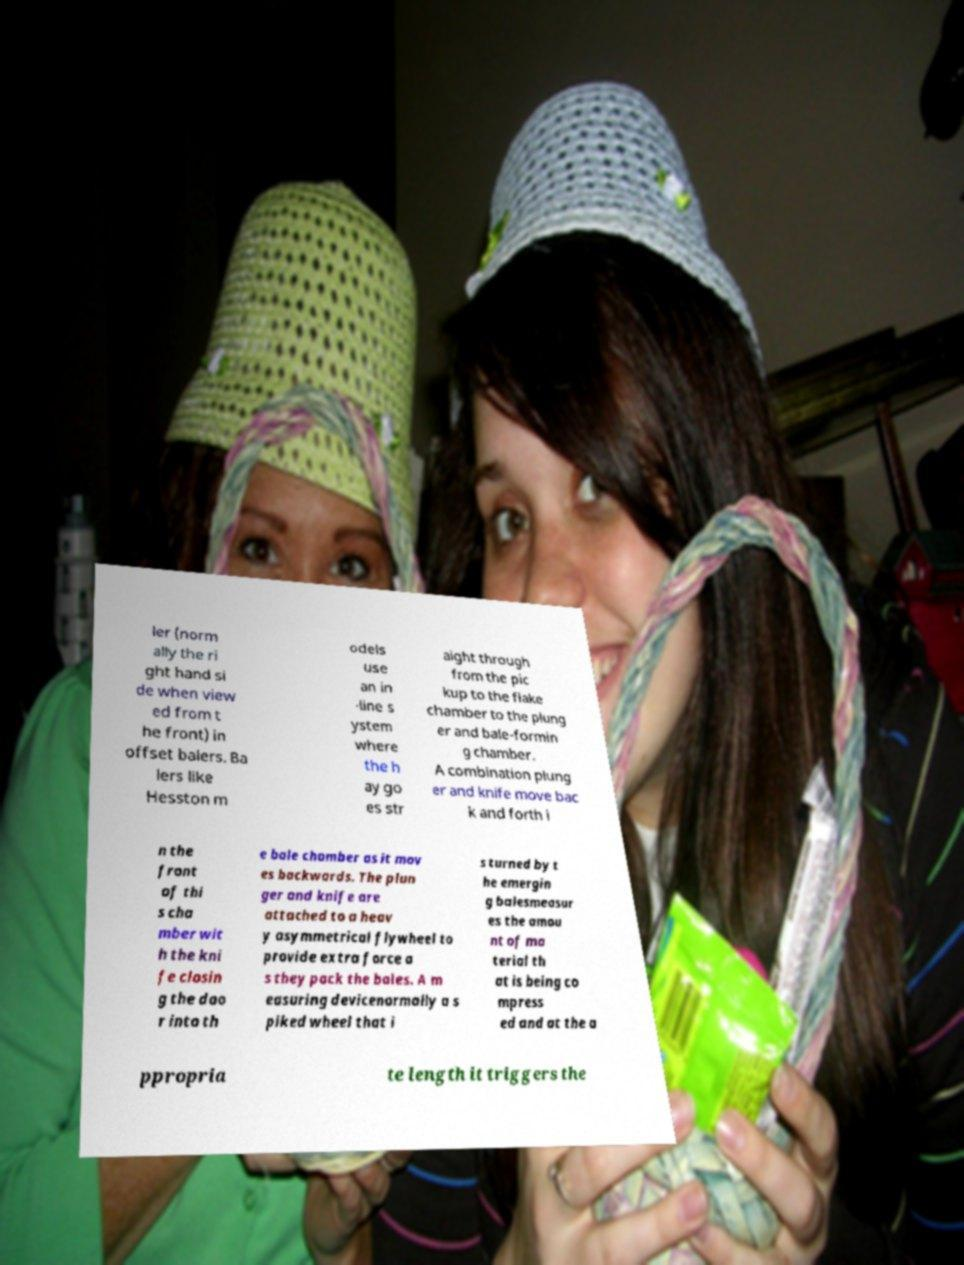Could you extract and type out the text from this image? ler (norm ally the ri ght hand si de when view ed from t he front) in offset balers. Ba lers like Hesston m odels use an in -line s ystem where the h ay go es str aight through from the pic kup to the flake chamber to the plung er and bale-formin g chamber. A combination plung er and knife move bac k and forth i n the front of thi s cha mber wit h the kni fe closin g the doo r into th e bale chamber as it mov es backwards. The plun ger and knife are attached to a heav y asymmetrical flywheel to provide extra force a s they pack the bales. A m easuring devicenormally a s piked wheel that i s turned by t he emergin g balesmeasur es the amou nt of ma terial th at is being co mpress ed and at the a ppropria te length it triggers the 